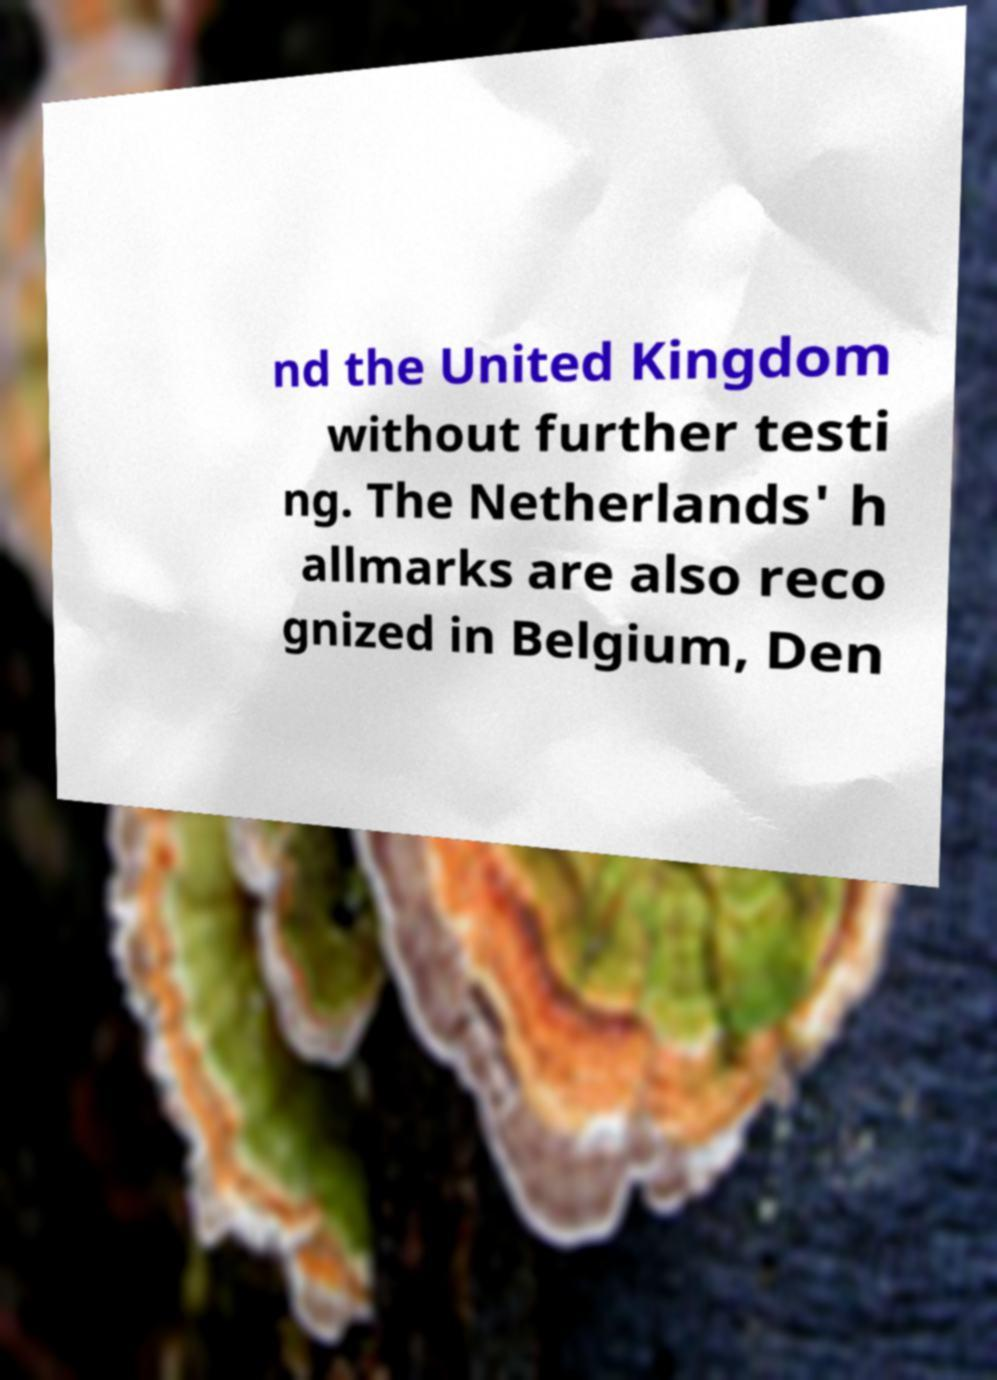Please identify and transcribe the text found in this image. nd the United Kingdom without further testi ng. The Netherlands' h allmarks are also reco gnized in Belgium, Den 